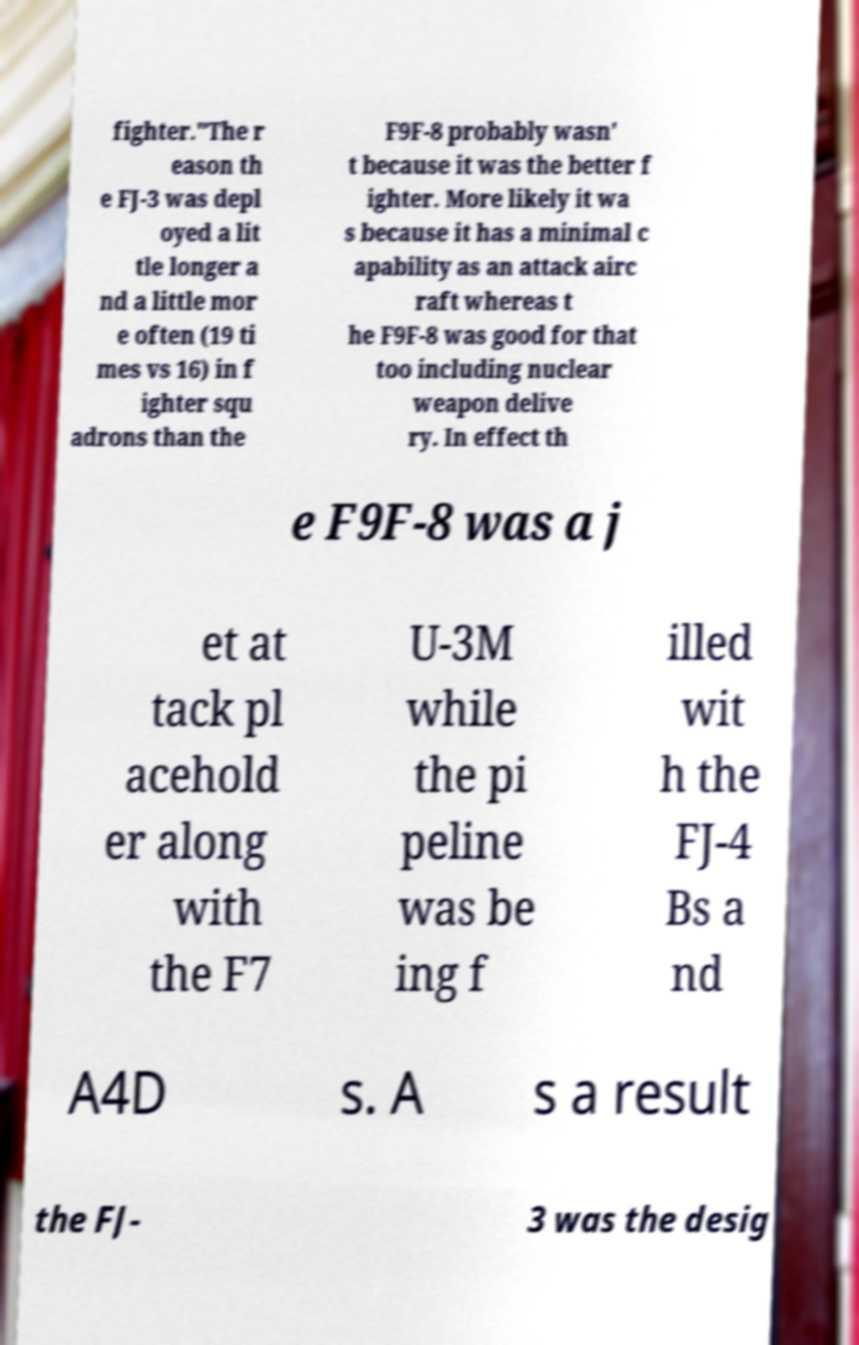Can you read and provide the text displayed in the image?This photo seems to have some interesting text. Can you extract and type it out for me? fighter."The r eason th e FJ-3 was depl oyed a lit tle longer a nd a little mor e often (19 ti mes vs 16) in f ighter squ adrons than the F9F-8 probably wasn' t because it was the better f ighter. More likely it wa s because it has a minimal c apability as an attack airc raft whereas t he F9F-8 was good for that too including nuclear weapon delive ry. In effect th e F9F-8 was a j et at tack pl acehold er along with the F7 U-3M while the pi peline was be ing f illed wit h the FJ-4 Bs a nd A4D s. A s a result the FJ- 3 was the desig 